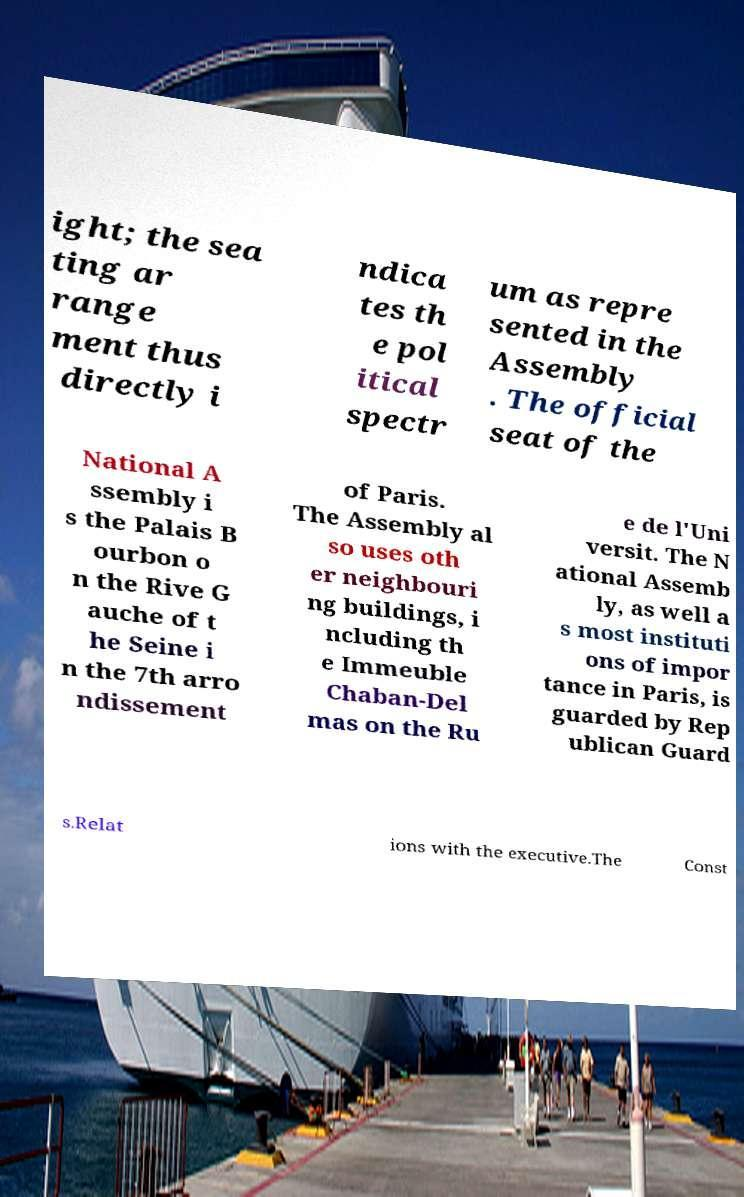Please identify and transcribe the text found in this image. ight; the sea ting ar range ment thus directly i ndica tes th e pol itical spectr um as repre sented in the Assembly . The official seat of the National A ssembly i s the Palais B ourbon o n the Rive G auche of t he Seine i n the 7th arro ndissement of Paris. The Assembly al so uses oth er neighbouri ng buildings, i ncluding th e Immeuble Chaban-Del mas on the Ru e de l'Uni versit. The N ational Assemb ly, as well a s most instituti ons of impor tance in Paris, is guarded by Rep ublican Guard s.Relat ions with the executive.The Const 